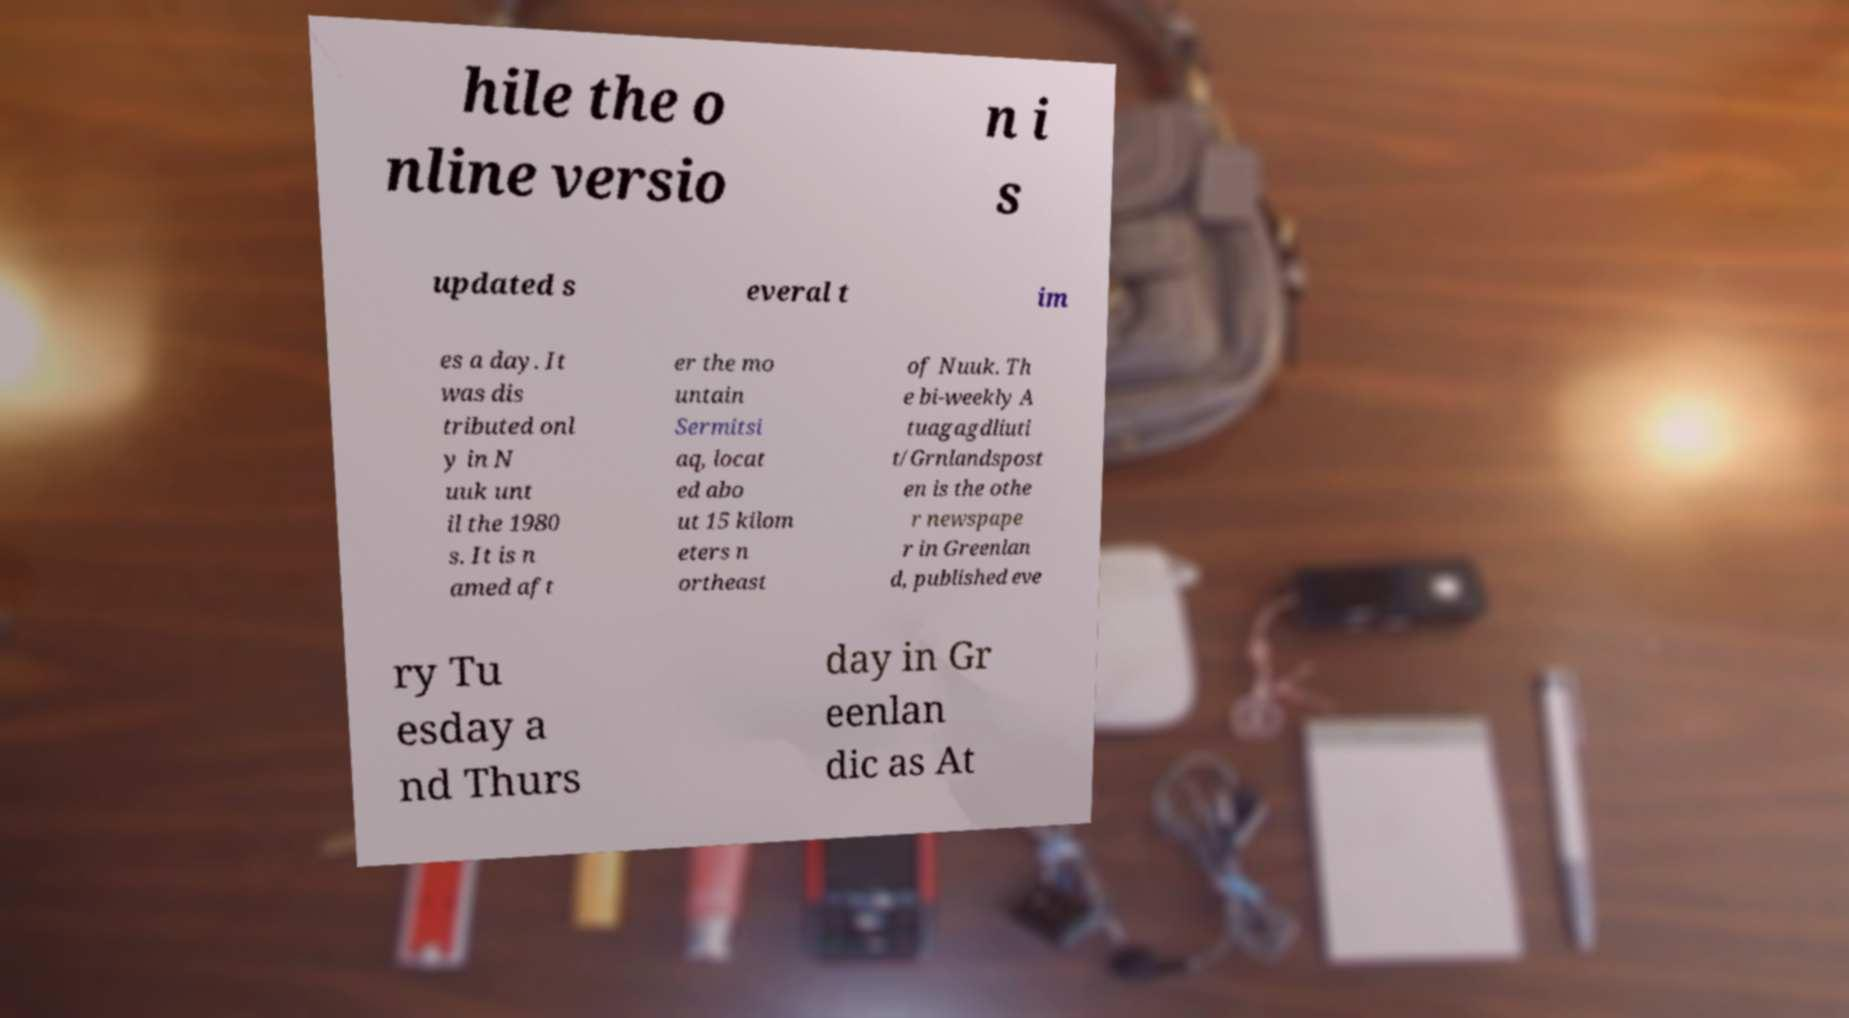For documentation purposes, I need the text within this image transcribed. Could you provide that? hile the o nline versio n i s updated s everal t im es a day. It was dis tributed onl y in N uuk unt il the 1980 s. It is n amed aft er the mo untain Sermitsi aq, locat ed abo ut 15 kilom eters n ortheast of Nuuk. Th e bi-weekly A tuagagdliuti t/Grnlandspost en is the othe r newspape r in Greenlan d, published eve ry Tu esday a nd Thurs day in Gr eenlan dic as At 